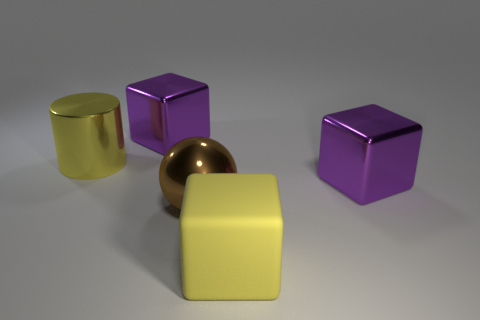Considering the composition of the shapes presented, what can you deduce about their possible uses in a real-life scenario? In a real-life scenario, the cubes could serve as placeholders for furniture or larger architectural elements due to their solid and stable shape, while the cylinder might represent objects like containers or pipes, considering their rounded shape and smooth texture. 